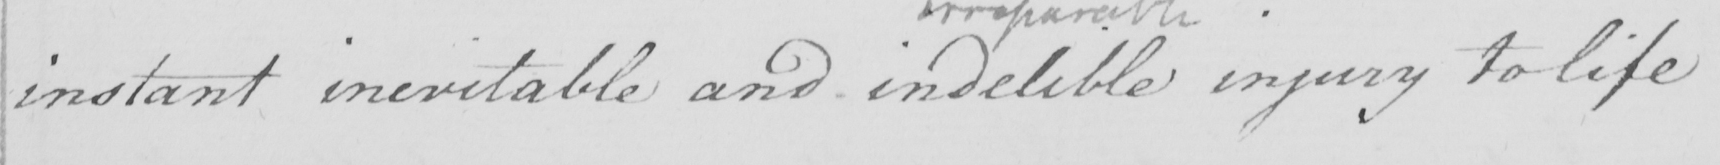Please transcribe the handwritten text in this image. instant inevitable and indelible injury to life 